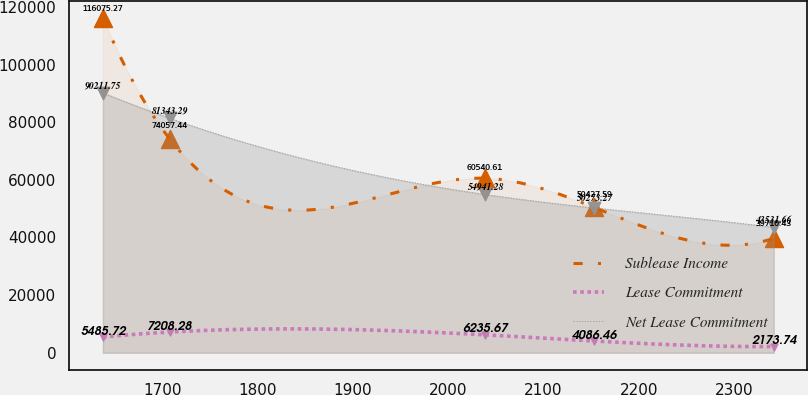<chart> <loc_0><loc_0><loc_500><loc_500><line_chart><ecel><fcel>Sublease Income<fcel>Lease Commitment<fcel>Net Lease Commitment<nl><fcel>1637.93<fcel>116075<fcel>5485.72<fcel>90211.8<nl><fcel>1708.3<fcel>74057.4<fcel>7208.28<fcel>81343.3<nl><fcel>2038.68<fcel>60540.6<fcel>6235.67<fcel>54941.3<nl><fcel>2153.27<fcel>50427.6<fcel>4086.46<fcel>50273.3<nl><fcel>2341.61<fcel>39710.4<fcel>2173.74<fcel>43531.7<nl></chart> 